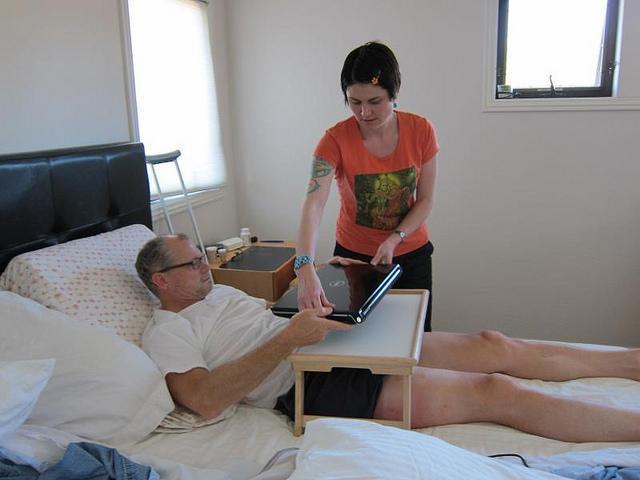How many people are in the photo?
Give a very brief answer. 2. How many red umbrellas are there?
Give a very brief answer. 0. 